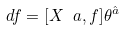Convert formula to latex. <formula><loc_0><loc_0><loc_500><loc_500>d { f } = [ X _ { \ } a , { f } ] \theta ^ { \hat { a } }</formula> 